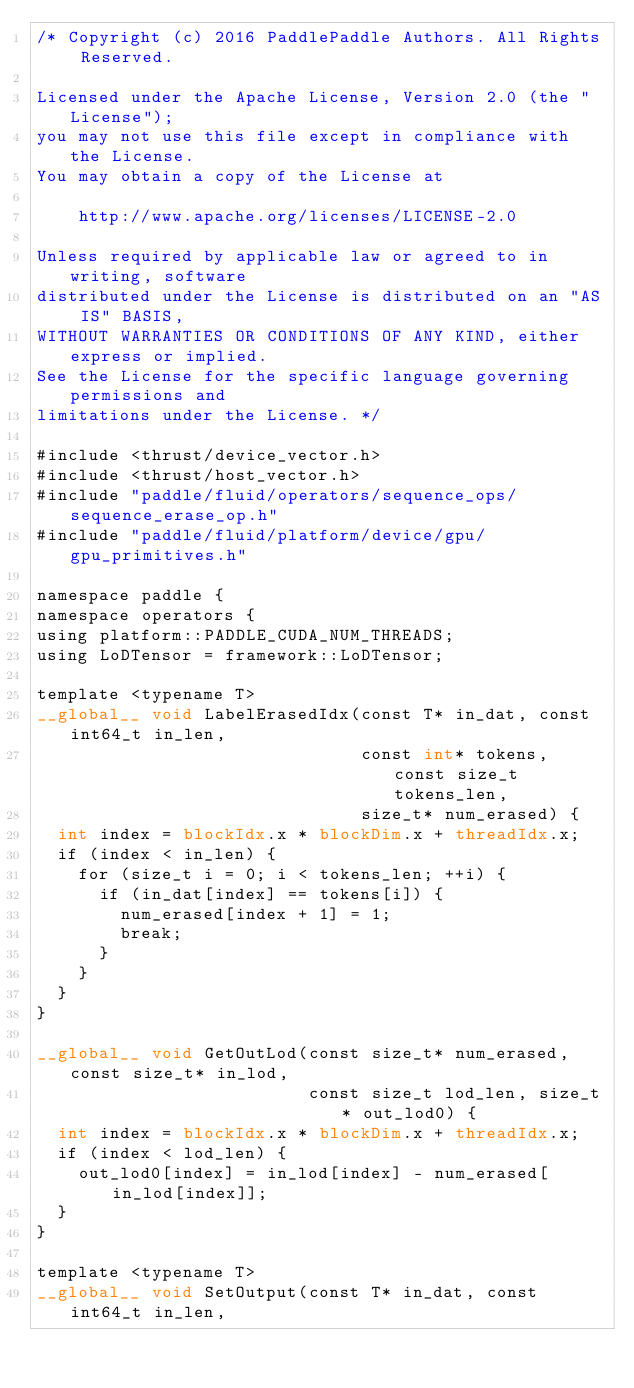<code> <loc_0><loc_0><loc_500><loc_500><_Cuda_>/* Copyright (c) 2016 PaddlePaddle Authors. All Rights Reserved.

Licensed under the Apache License, Version 2.0 (the "License");
you may not use this file except in compliance with the License.
You may obtain a copy of the License at

    http://www.apache.org/licenses/LICENSE-2.0

Unless required by applicable law or agreed to in writing, software
distributed under the License is distributed on an "AS IS" BASIS,
WITHOUT WARRANTIES OR CONDITIONS OF ANY KIND, either express or implied.
See the License for the specific language governing permissions and
limitations under the License. */

#include <thrust/device_vector.h>
#include <thrust/host_vector.h>
#include "paddle/fluid/operators/sequence_ops/sequence_erase_op.h"
#include "paddle/fluid/platform/device/gpu/gpu_primitives.h"

namespace paddle {
namespace operators {
using platform::PADDLE_CUDA_NUM_THREADS;
using LoDTensor = framework::LoDTensor;

template <typename T>
__global__ void LabelErasedIdx(const T* in_dat, const int64_t in_len,
                               const int* tokens, const size_t tokens_len,
                               size_t* num_erased) {
  int index = blockIdx.x * blockDim.x + threadIdx.x;
  if (index < in_len) {
    for (size_t i = 0; i < tokens_len; ++i) {
      if (in_dat[index] == tokens[i]) {
        num_erased[index + 1] = 1;
        break;
      }
    }
  }
}

__global__ void GetOutLod(const size_t* num_erased, const size_t* in_lod,
                          const size_t lod_len, size_t* out_lod0) {
  int index = blockIdx.x * blockDim.x + threadIdx.x;
  if (index < lod_len) {
    out_lod0[index] = in_lod[index] - num_erased[in_lod[index]];
  }
}

template <typename T>
__global__ void SetOutput(const T* in_dat, const int64_t in_len,</code> 